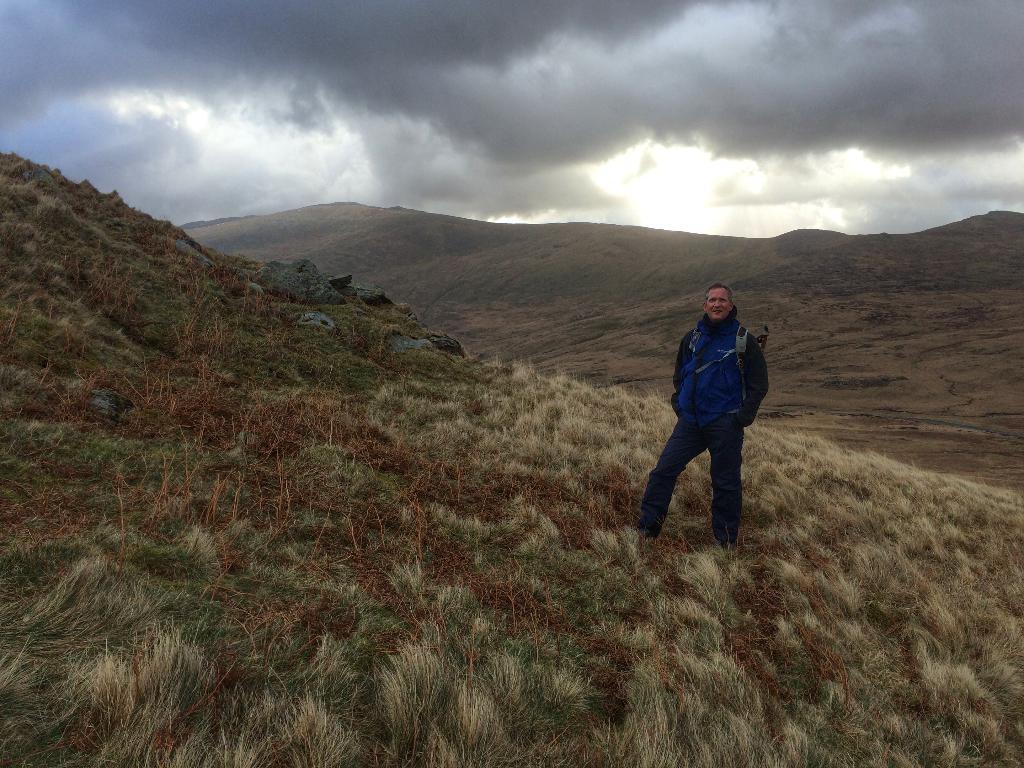How would you summarize this image in a sentence or two? In this picture I can see a person standing , there is grass, hills, and in the background there is sky. 